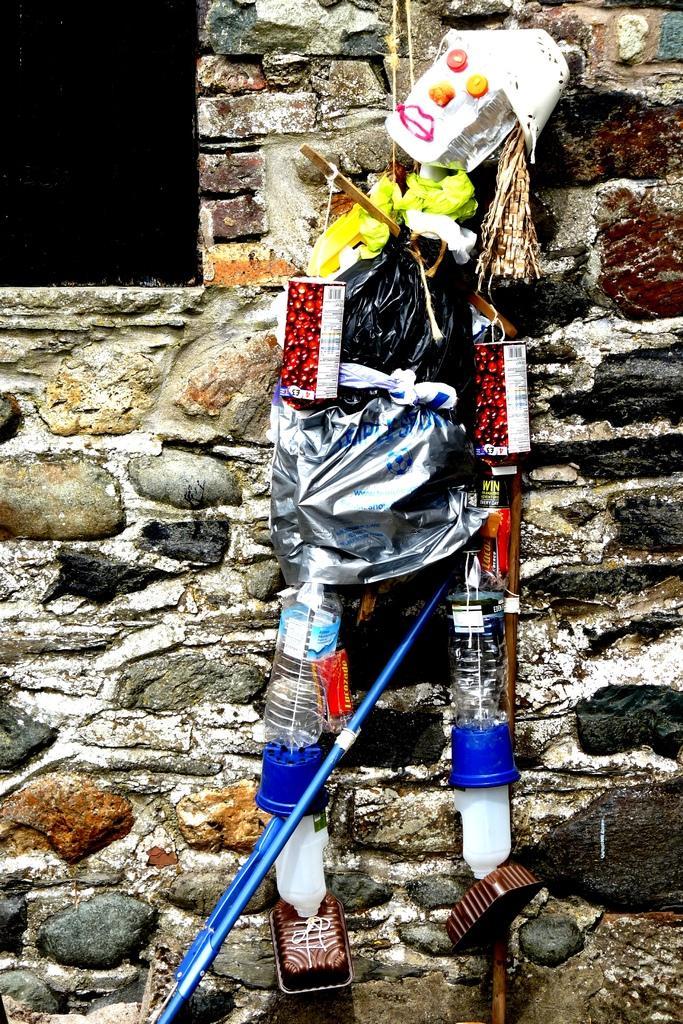Could you give a brief overview of what you see in this image? In this picture I can see the objects which is in the shape of a person. I can see the wall in the background. 